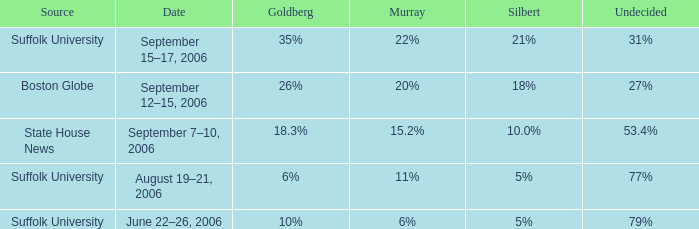What is the undecided percentage of the poll from Suffolk University with Murray at 11%? 77%. Give me the full table as a dictionary. {'header': ['Source', 'Date', 'Goldberg', 'Murray', 'Silbert', 'Undecided'], 'rows': [['Suffolk University', 'September 15–17, 2006', '35%', '22%', '21%', '31%'], ['Boston Globe', 'September 12–15, 2006', '26%', '20%', '18%', '27%'], ['State House News', 'September 7–10, 2006', '18.3%', '15.2%', '10.0%', '53.4%'], ['Suffolk University', 'August 19–21, 2006', '6%', '11%', '5%', '77%'], ['Suffolk University', 'June 22–26, 2006', '10%', '6%', '5%', '79%']]} 